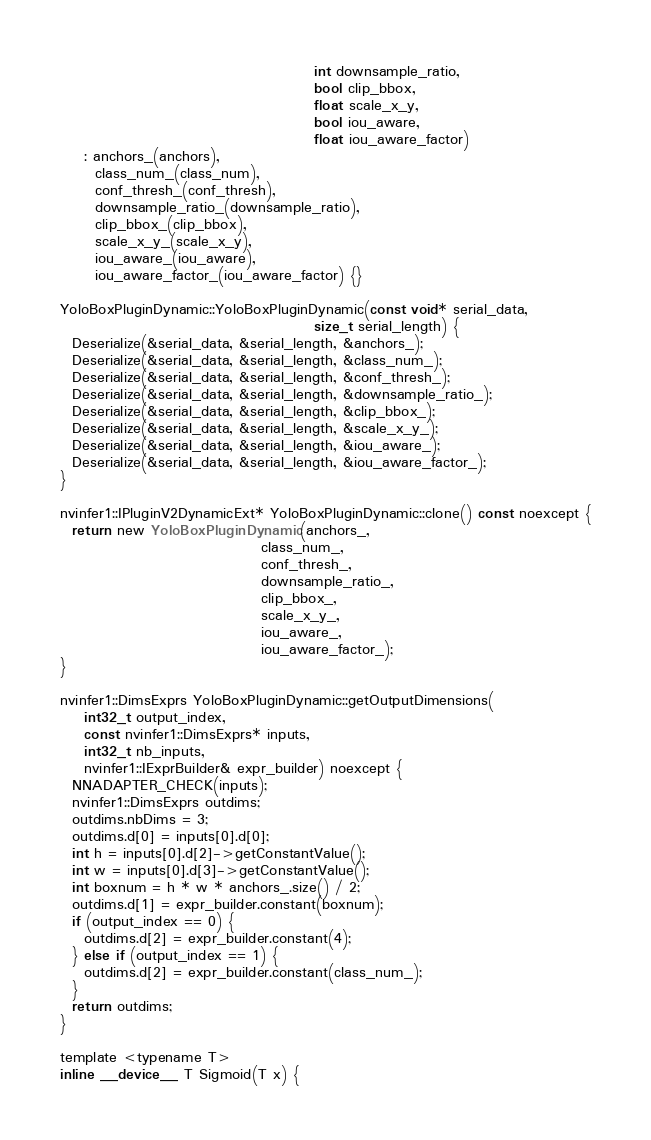<code> <loc_0><loc_0><loc_500><loc_500><_Cuda_>                                           int downsample_ratio,
                                           bool clip_bbox,
                                           float scale_x_y,
                                           bool iou_aware,
                                           float iou_aware_factor)
    : anchors_(anchors),
      class_num_(class_num),
      conf_thresh_(conf_thresh),
      downsample_ratio_(downsample_ratio),
      clip_bbox_(clip_bbox),
      scale_x_y_(scale_x_y),
      iou_aware_(iou_aware),
      iou_aware_factor_(iou_aware_factor) {}

YoloBoxPluginDynamic::YoloBoxPluginDynamic(const void* serial_data,
                                           size_t serial_length) {
  Deserialize(&serial_data, &serial_length, &anchors_);
  Deserialize(&serial_data, &serial_length, &class_num_);
  Deserialize(&serial_data, &serial_length, &conf_thresh_);
  Deserialize(&serial_data, &serial_length, &downsample_ratio_);
  Deserialize(&serial_data, &serial_length, &clip_bbox_);
  Deserialize(&serial_data, &serial_length, &scale_x_y_);
  Deserialize(&serial_data, &serial_length, &iou_aware_);
  Deserialize(&serial_data, &serial_length, &iou_aware_factor_);
}

nvinfer1::IPluginV2DynamicExt* YoloBoxPluginDynamic::clone() const noexcept {
  return new YoloBoxPluginDynamic(anchors_,
                                  class_num_,
                                  conf_thresh_,
                                  downsample_ratio_,
                                  clip_bbox_,
                                  scale_x_y_,
                                  iou_aware_,
                                  iou_aware_factor_);
}

nvinfer1::DimsExprs YoloBoxPluginDynamic::getOutputDimensions(
    int32_t output_index,
    const nvinfer1::DimsExprs* inputs,
    int32_t nb_inputs,
    nvinfer1::IExprBuilder& expr_builder) noexcept {
  NNADAPTER_CHECK(inputs);
  nvinfer1::DimsExprs outdims;
  outdims.nbDims = 3;
  outdims.d[0] = inputs[0].d[0];
  int h = inputs[0].d[2]->getConstantValue();
  int w = inputs[0].d[3]->getConstantValue();
  int boxnum = h * w * anchors_.size() / 2;
  outdims.d[1] = expr_builder.constant(boxnum);
  if (output_index == 0) {
    outdims.d[2] = expr_builder.constant(4);
  } else if (output_index == 1) {
    outdims.d[2] = expr_builder.constant(class_num_);
  }
  return outdims;
}

template <typename T>
inline __device__ T Sigmoid(T x) {</code> 